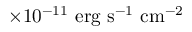Convert formula to latex. <formula><loc_0><loc_0><loc_500><loc_500>\times 1 0 ^ { - 1 1 } { \ e r g \ s ^ { - 1 } \ c m ^ { - 2 } }</formula> 